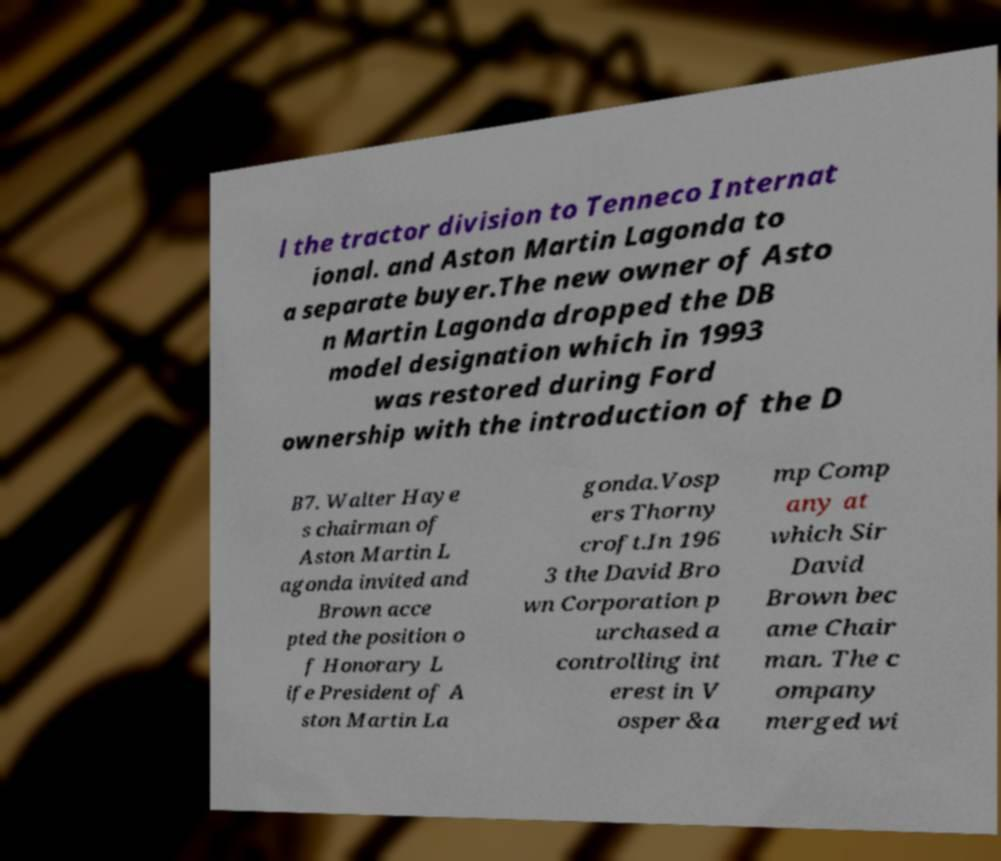Please read and relay the text visible in this image. What does it say? l the tractor division to Tenneco Internat ional. and Aston Martin Lagonda to a separate buyer.The new owner of Asto n Martin Lagonda dropped the DB model designation which in 1993 was restored during Ford ownership with the introduction of the D B7. Walter Haye s chairman of Aston Martin L agonda invited and Brown acce pted the position o f Honorary L ife President of A ston Martin La gonda.Vosp ers Thorny croft.In 196 3 the David Bro wn Corporation p urchased a controlling int erest in V osper &a mp Comp any at which Sir David Brown bec ame Chair man. The c ompany merged wi 